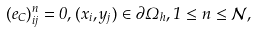<formula> <loc_0><loc_0><loc_500><loc_500>( e _ { C } ) _ { i j } ^ { n } = 0 , ( x _ { i } , y _ { j } ) \in \partial \Omega _ { h } , 1 \leq n \leq \mathcal { N } ,</formula> 